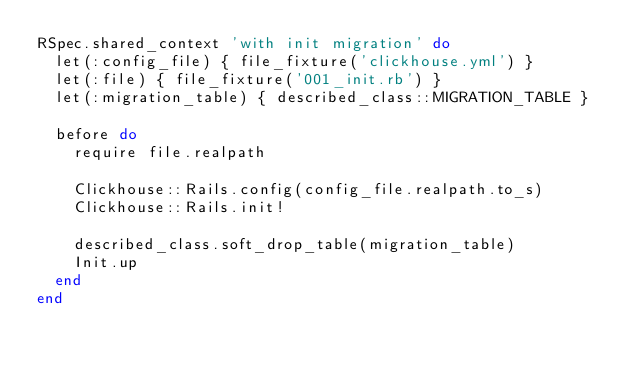<code> <loc_0><loc_0><loc_500><loc_500><_Ruby_>RSpec.shared_context 'with init migration' do
  let(:config_file) { file_fixture('clickhouse.yml') }
  let(:file) { file_fixture('001_init.rb') }
  let(:migration_table) { described_class::MIGRATION_TABLE }

  before do
    require file.realpath

    Clickhouse::Rails.config(config_file.realpath.to_s)
    Clickhouse::Rails.init!

    described_class.soft_drop_table(migration_table)
    Init.up
  end
end
</code> 